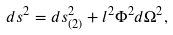Convert formula to latex. <formula><loc_0><loc_0><loc_500><loc_500>d s ^ { 2 } = d s _ { ( 2 ) } ^ { 2 } + l ^ { 2 } \Phi ^ { 2 } d \Omega ^ { 2 } ,</formula> 